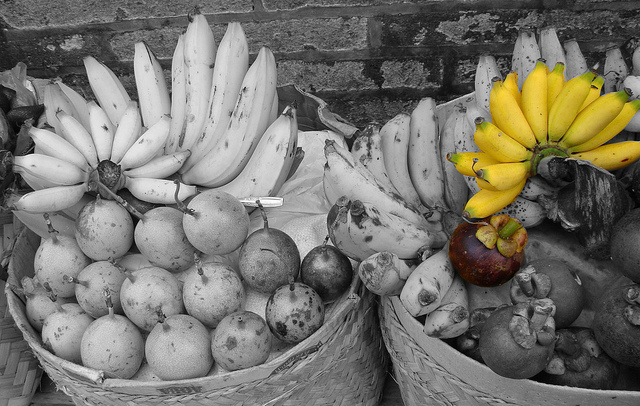Pick out the most intriguing fruit and describe its possible taste and texture. The most intriguing fruit in the image is the single, large purple fruit in the right basket. This exotic-looking fruit likely has a rich, sweet yet tangy flavor, with a texture that is both juicy and creamy. The outer skin appears thick and robust, possibly hinting at a tender and succulent flesh inside, bursting with unique and refreshing taste along with unexpected hints of spices. 